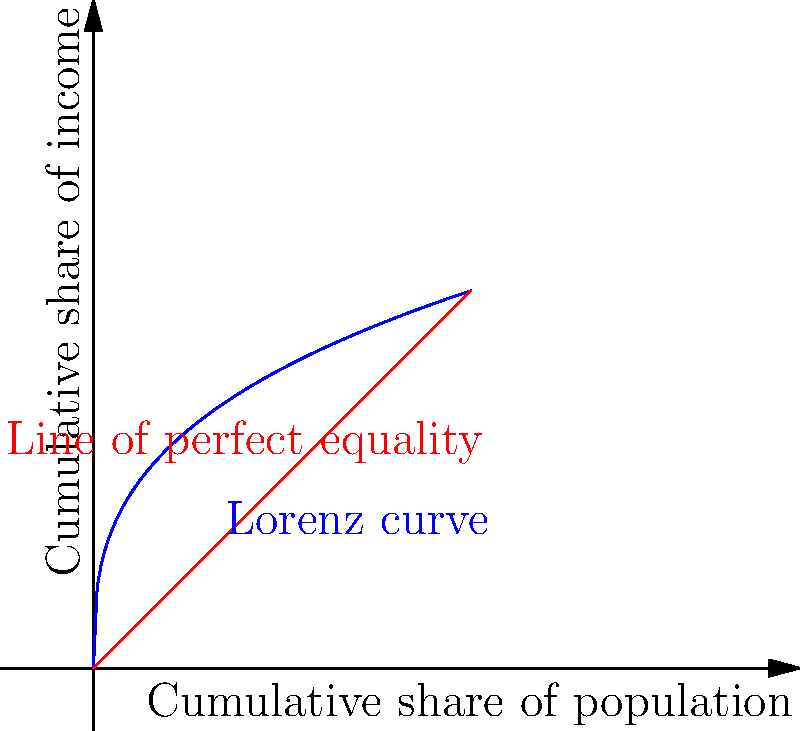In your studies with Professor Tony Judt on economic history, you encounter a Lorenz curve representing income distribution in a particular country. Given the Lorenz curve shown in the graph, calculate the Gini coefficient to assess the level of income inequality. Assume the area between the line of perfect equality and the Lorenz curve is 0.3. To calculate the Gini coefficient, we'll follow these steps:

1) Recall the formula for the Gini coefficient:
   $$ G = \frac{A}{A+B} $$
   where A is the area between the line of perfect equality and the Lorenz curve, and B is the area under the Lorenz curve.

2) We're given that A = 0.3

3) The total area of the triangle formed by the line of perfect equality is 0.5 (half of a 1x1 square)

4) Therefore, A + B = 0.5

5) We can find B by subtracting A from the total area:
   $$ B = 0.5 - 0.3 = 0.2 $$

6) Now we can plug these values into the Gini coefficient formula:
   $$ G = \frac{0.3}{0.3+0.2} = \frac{0.3}{0.5} = 0.6 $$

Thus, the Gini coefficient for this income distribution is 0.6.
Answer: 0.6 